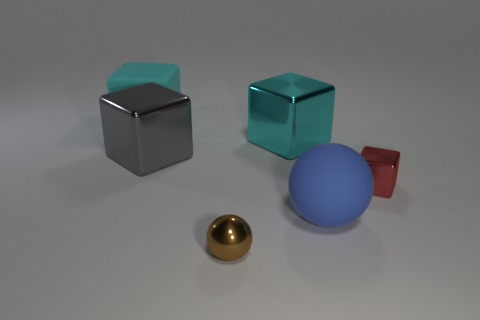Add 2 large blue rubber balls. How many objects exist? 8 Subtract all balls. How many objects are left? 4 Add 1 big balls. How many big balls are left? 2 Add 2 red rubber cylinders. How many red rubber cylinders exist? 2 Subtract 0 gray cylinders. How many objects are left? 6 Subtract all big cyan matte objects. Subtract all red metallic objects. How many objects are left? 4 